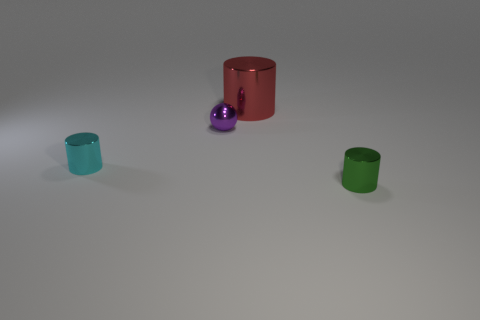Add 3 big red cubes. How many objects exist? 7 Subtract all balls. How many objects are left? 3 Subtract all cyan metallic cylinders. Subtract all yellow cubes. How many objects are left? 3 Add 2 big red objects. How many big red objects are left? 3 Add 3 large brown rubber objects. How many large brown rubber objects exist? 3 Subtract 0 cyan spheres. How many objects are left? 4 